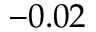Convert formula to latex. <formula><loc_0><loc_0><loc_500><loc_500>- 0 . 0 2</formula> 